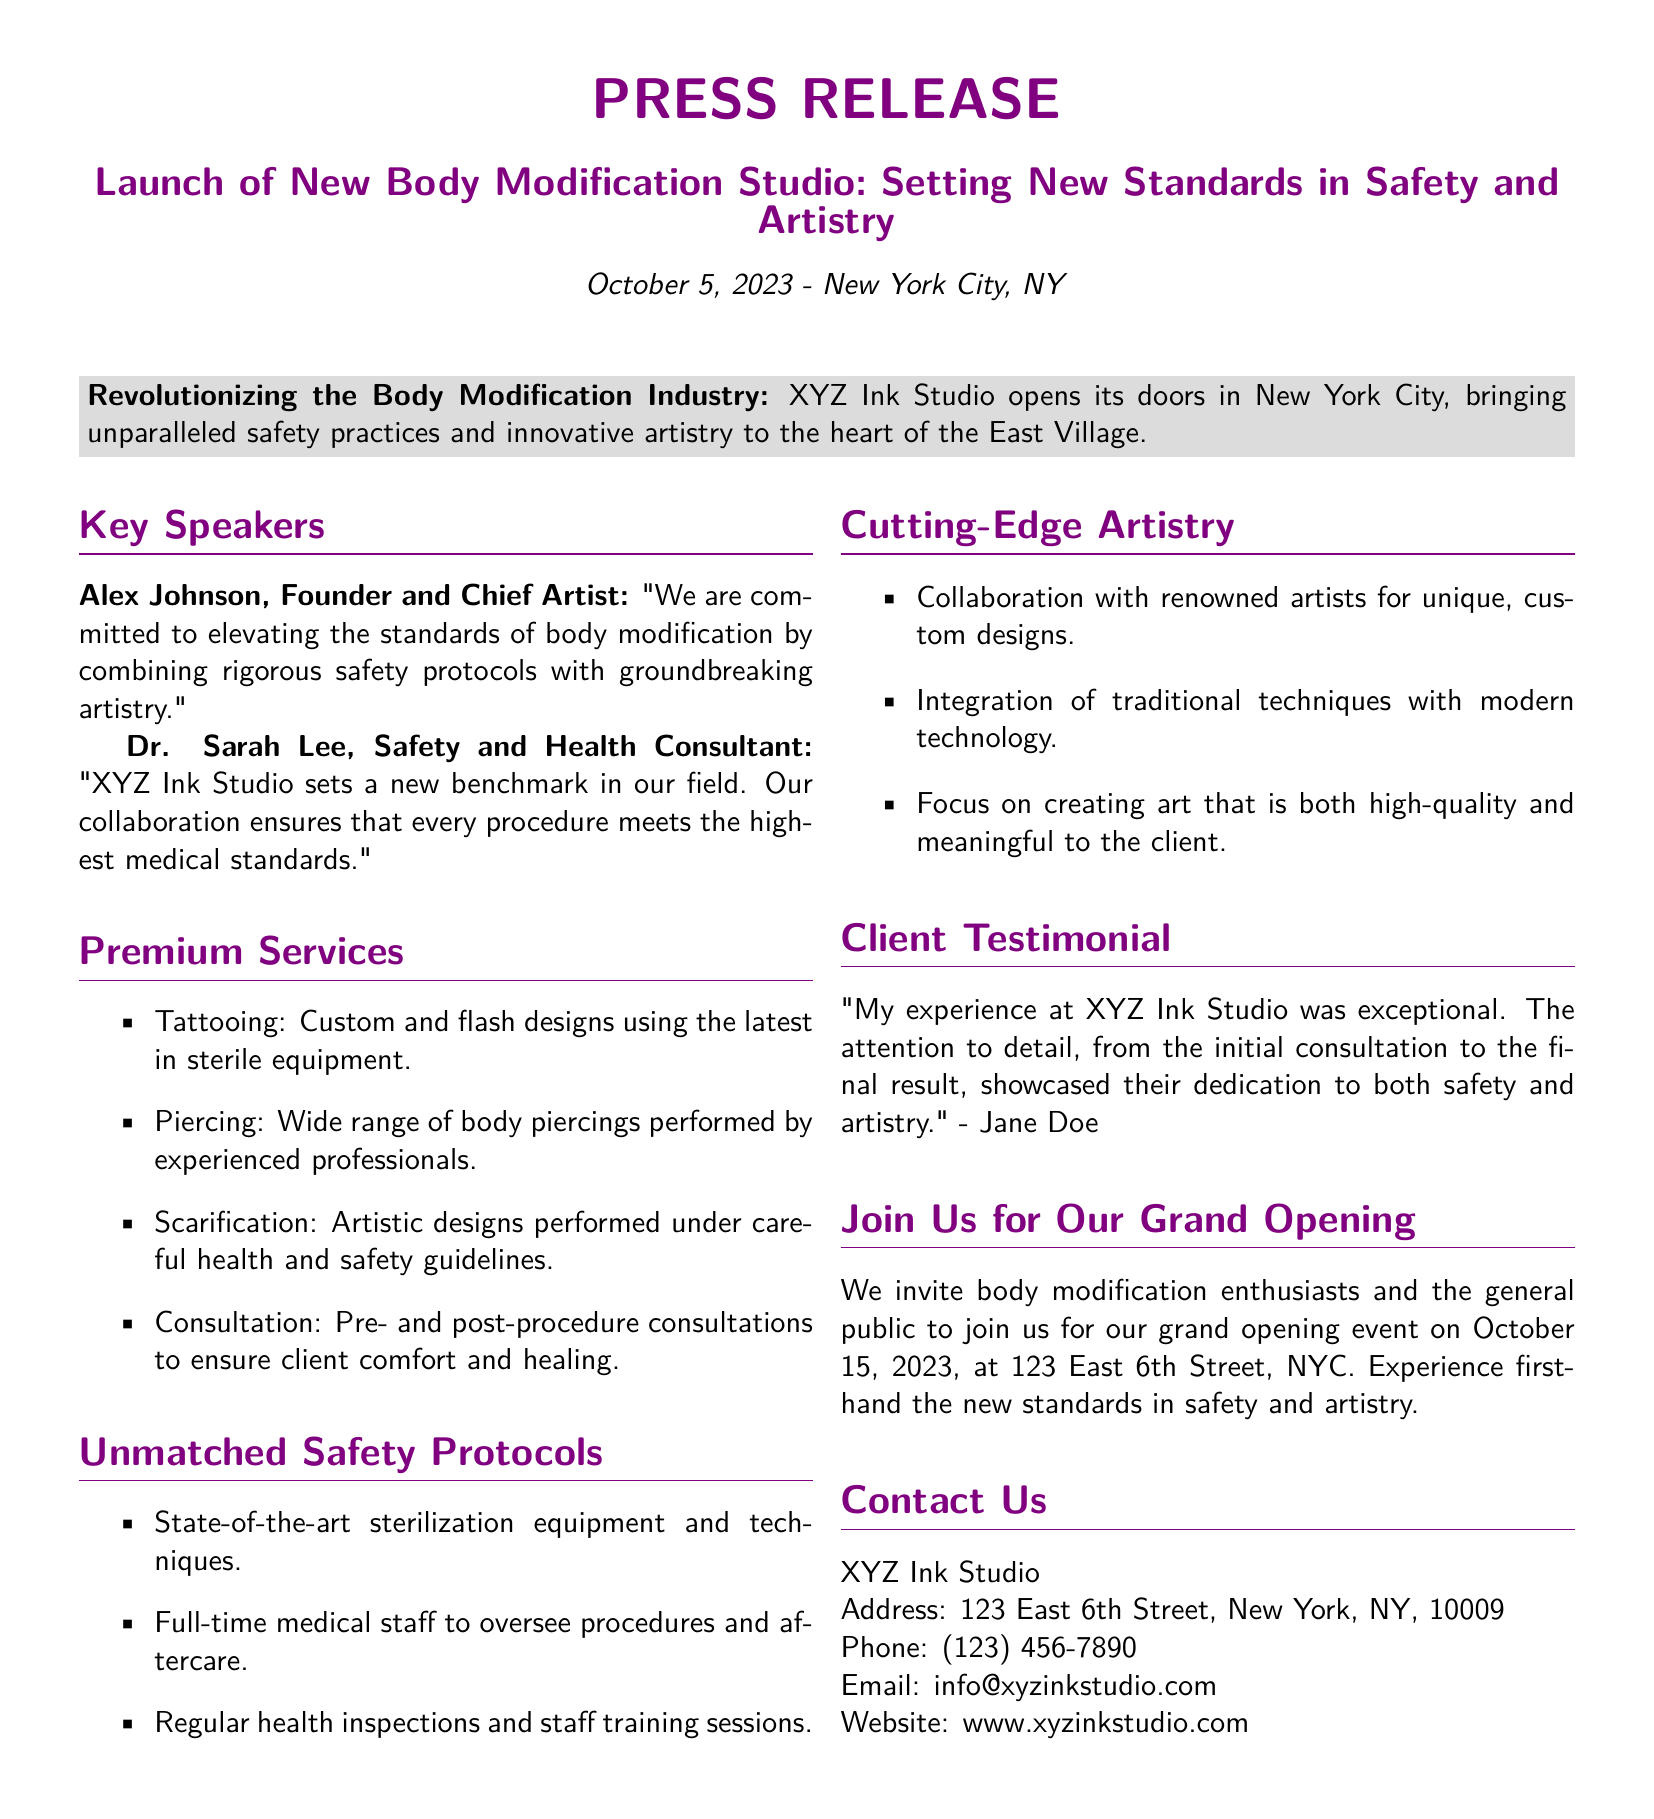What is the name of the new body modification studio? The document states that the name of the studio is XYZ Ink Studio.
Answer: XYZ Ink Studio Who is the founder and chief artist of the studio? The document mentions Alex Johnson as the founder and chief artist of the studio.
Answer: Alex Johnson When is the grand opening event scheduled? The document specifies that the grand opening event is on October 15, 2023.
Answer: October 15, 2023 What types of services does XYZ Ink Studio offer? The document lists services such as tattooing, piercing, scarification, and consultation.
Answer: Tattooing, piercing, scarification, consultation What is one of the safety protocols mentioned? The document highlights that the studio uses state-of-the-art sterilization equipment and techniques as a safety protocol.
Answer: State-of-the-art sterilization equipment What is a feature of the cutting-edge artistry at the studio? The document indicates a collaboration with renowned artists for unique, custom designs as part of their artistry.
Answer: Collaboration with renowned artists Who provided a testimonial in the press release? The document records Jane Doe as the person who provided a testimonial about her experience at the studio.
Answer: Jane Doe Where is the studio located? The document provides the address of the studio as 123 East 6th Street, New York, NY, 10009.
Answer: 123 East 6th Street, New York, NY, 10009 